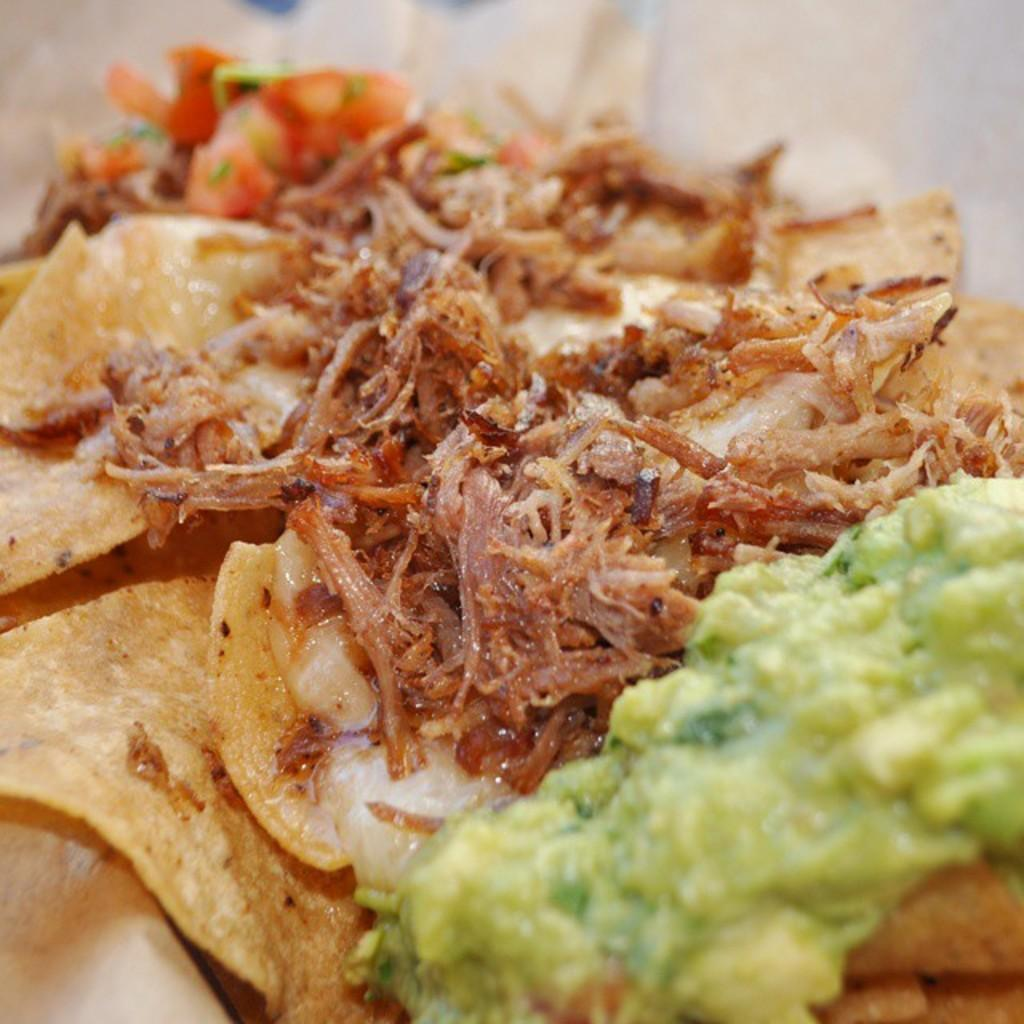What is the main subject of the image? There is a food item in the center of the image. What type of credit can be seen being issued to the team in the hospital in the image? There is no credit, team, or hospital present in the image; it only features a food item in the center. 